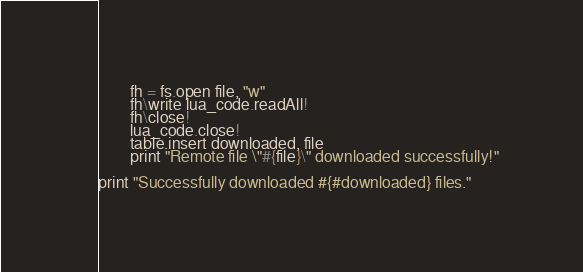Convert code to text. <code><loc_0><loc_0><loc_500><loc_500><_MoonScript_>        fh = fs.open file, "w"
        fh\write lua_code.readAll!
        fh\close!
        lua_code.close!
        table.insert downloaded, file
        print "Remote file \"#{file}\" downloaded successfully!"

print "Successfully downloaded #{#downloaded} files."

</code> 